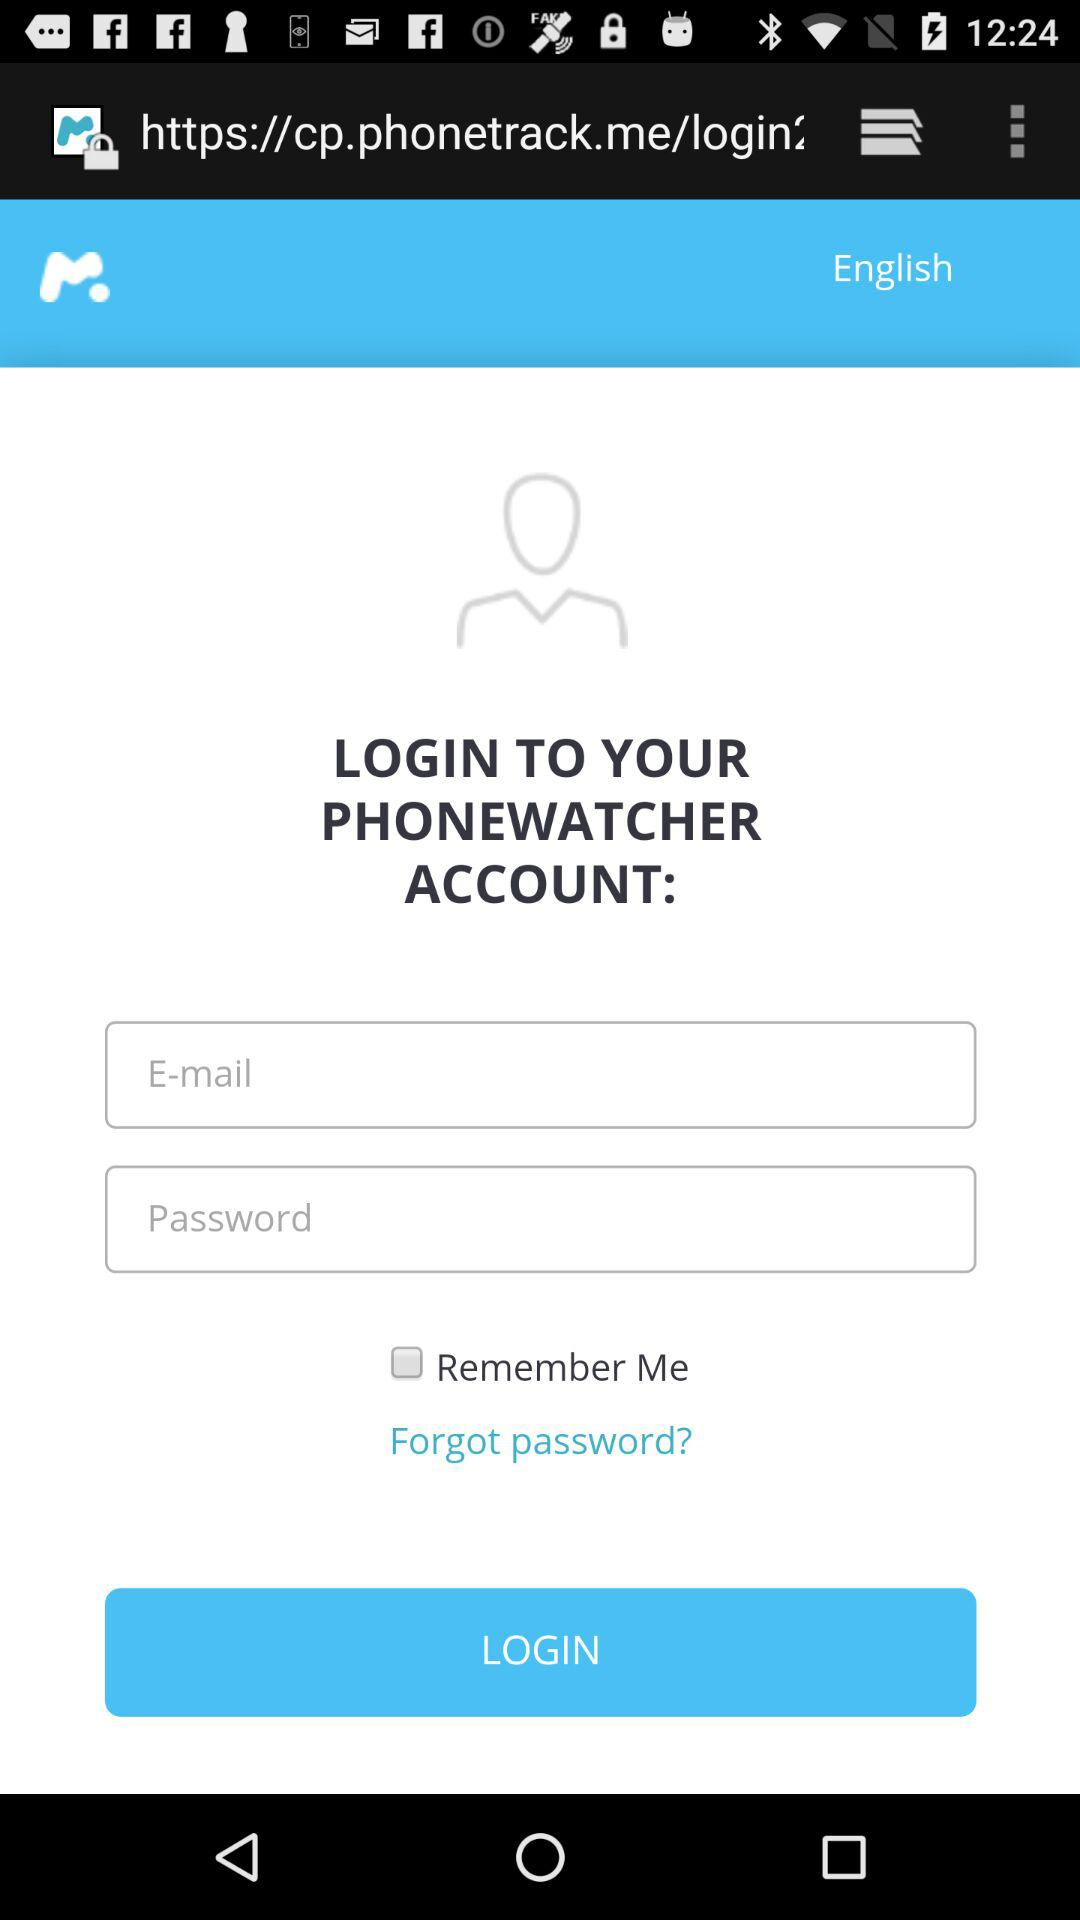What is the status of "Remember Me"? The status is "off". 